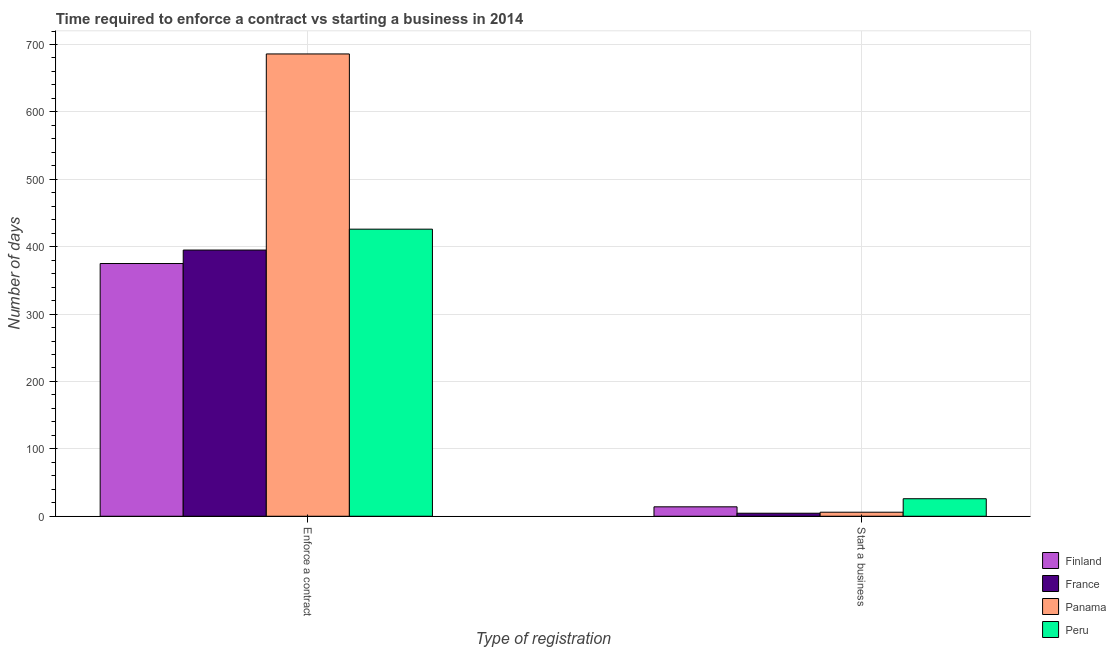How many groups of bars are there?
Your answer should be compact. 2. Are the number of bars per tick equal to the number of legend labels?
Your answer should be very brief. Yes. How many bars are there on the 2nd tick from the right?
Provide a short and direct response. 4. What is the label of the 1st group of bars from the left?
Make the answer very short. Enforce a contract. What is the number of days to enforece a contract in France?
Your response must be concise. 395. Across all countries, what is the maximum number of days to enforece a contract?
Your answer should be very brief. 686. Across all countries, what is the minimum number of days to enforece a contract?
Your answer should be compact. 375. In which country was the number of days to enforece a contract maximum?
Give a very brief answer. Panama. What is the total number of days to enforece a contract in the graph?
Provide a short and direct response. 1882. What is the difference between the number of days to enforece a contract in Panama and that in France?
Provide a succinct answer. 291. What is the difference between the number of days to start a business in Finland and the number of days to enforece a contract in France?
Your response must be concise. -381. What is the average number of days to enforece a contract per country?
Make the answer very short. 470.5. What is the ratio of the number of days to enforece a contract in France to that in Peru?
Offer a very short reply. 0.93. Is the number of days to start a business in France less than that in Panama?
Your response must be concise. Yes. What does the 3rd bar from the right in Start a business represents?
Keep it short and to the point. France. Are all the bars in the graph horizontal?
Make the answer very short. No. What is the difference between two consecutive major ticks on the Y-axis?
Give a very brief answer. 100. Are the values on the major ticks of Y-axis written in scientific E-notation?
Offer a terse response. No. Does the graph contain grids?
Make the answer very short. Yes. How are the legend labels stacked?
Offer a terse response. Vertical. What is the title of the graph?
Keep it short and to the point. Time required to enforce a contract vs starting a business in 2014. Does "European Union" appear as one of the legend labels in the graph?
Provide a succinct answer. No. What is the label or title of the X-axis?
Keep it short and to the point. Type of registration. What is the label or title of the Y-axis?
Your response must be concise. Number of days. What is the Number of days in Finland in Enforce a contract?
Offer a very short reply. 375. What is the Number of days of France in Enforce a contract?
Your answer should be compact. 395. What is the Number of days of Panama in Enforce a contract?
Ensure brevity in your answer.  686. What is the Number of days of Peru in Enforce a contract?
Provide a short and direct response. 426. What is the Number of days of Finland in Start a business?
Offer a very short reply. 14. What is the Number of days of France in Start a business?
Give a very brief answer. 4.5. Across all Type of registration, what is the maximum Number of days of Finland?
Make the answer very short. 375. Across all Type of registration, what is the maximum Number of days in France?
Provide a short and direct response. 395. Across all Type of registration, what is the maximum Number of days in Panama?
Ensure brevity in your answer.  686. Across all Type of registration, what is the maximum Number of days of Peru?
Provide a short and direct response. 426. Across all Type of registration, what is the minimum Number of days in Peru?
Your answer should be very brief. 26. What is the total Number of days in Finland in the graph?
Offer a terse response. 389. What is the total Number of days in France in the graph?
Provide a short and direct response. 399.5. What is the total Number of days in Panama in the graph?
Keep it short and to the point. 692. What is the total Number of days in Peru in the graph?
Your answer should be compact. 452. What is the difference between the Number of days of Finland in Enforce a contract and that in Start a business?
Offer a very short reply. 361. What is the difference between the Number of days in France in Enforce a contract and that in Start a business?
Make the answer very short. 390.5. What is the difference between the Number of days of Panama in Enforce a contract and that in Start a business?
Make the answer very short. 680. What is the difference between the Number of days in Finland in Enforce a contract and the Number of days in France in Start a business?
Give a very brief answer. 370.5. What is the difference between the Number of days of Finland in Enforce a contract and the Number of days of Panama in Start a business?
Offer a very short reply. 369. What is the difference between the Number of days in Finland in Enforce a contract and the Number of days in Peru in Start a business?
Ensure brevity in your answer.  349. What is the difference between the Number of days of France in Enforce a contract and the Number of days of Panama in Start a business?
Provide a short and direct response. 389. What is the difference between the Number of days of France in Enforce a contract and the Number of days of Peru in Start a business?
Ensure brevity in your answer.  369. What is the difference between the Number of days of Panama in Enforce a contract and the Number of days of Peru in Start a business?
Keep it short and to the point. 660. What is the average Number of days of Finland per Type of registration?
Make the answer very short. 194.5. What is the average Number of days in France per Type of registration?
Make the answer very short. 199.75. What is the average Number of days in Panama per Type of registration?
Offer a terse response. 346. What is the average Number of days of Peru per Type of registration?
Your answer should be compact. 226. What is the difference between the Number of days of Finland and Number of days of Panama in Enforce a contract?
Give a very brief answer. -311. What is the difference between the Number of days in Finland and Number of days in Peru in Enforce a contract?
Your answer should be very brief. -51. What is the difference between the Number of days in France and Number of days in Panama in Enforce a contract?
Your response must be concise. -291. What is the difference between the Number of days in France and Number of days in Peru in Enforce a contract?
Your answer should be very brief. -31. What is the difference between the Number of days in Panama and Number of days in Peru in Enforce a contract?
Your answer should be very brief. 260. What is the difference between the Number of days in Finland and Number of days in France in Start a business?
Offer a very short reply. 9.5. What is the difference between the Number of days of Finland and Number of days of Peru in Start a business?
Give a very brief answer. -12. What is the difference between the Number of days of France and Number of days of Peru in Start a business?
Your response must be concise. -21.5. What is the difference between the Number of days in Panama and Number of days in Peru in Start a business?
Keep it short and to the point. -20. What is the ratio of the Number of days in Finland in Enforce a contract to that in Start a business?
Provide a short and direct response. 26.79. What is the ratio of the Number of days of France in Enforce a contract to that in Start a business?
Your answer should be very brief. 87.78. What is the ratio of the Number of days of Panama in Enforce a contract to that in Start a business?
Provide a succinct answer. 114.33. What is the ratio of the Number of days of Peru in Enforce a contract to that in Start a business?
Offer a very short reply. 16.38. What is the difference between the highest and the second highest Number of days of Finland?
Keep it short and to the point. 361. What is the difference between the highest and the second highest Number of days of France?
Offer a terse response. 390.5. What is the difference between the highest and the second highest Number of days in Panama?
Make the answer very short. 680. What is the difference between the highest and the second highest Number of days of Peru?
Provide a short and direct response. 400. What is the difference between the highest and the lowest Number of days in Finland?
Offer a very short reply. 361. What is the difference between the highest and the lowest Number of days in France?
Ensure brevity in your answer.  390.5. What is the difference between the highest and the lowest Number of days in Panama?
Offer a terse response. 680. 